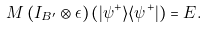<formula> <loc_0><loc_0><loc_500><loc_500>M \left ( I _ { B ^ { \prime } } \otimes \epsilon \right ) \left ( | \psi ^ { + } \rangle \langle \psi ^ { + } | \right ) = E .</formula> 